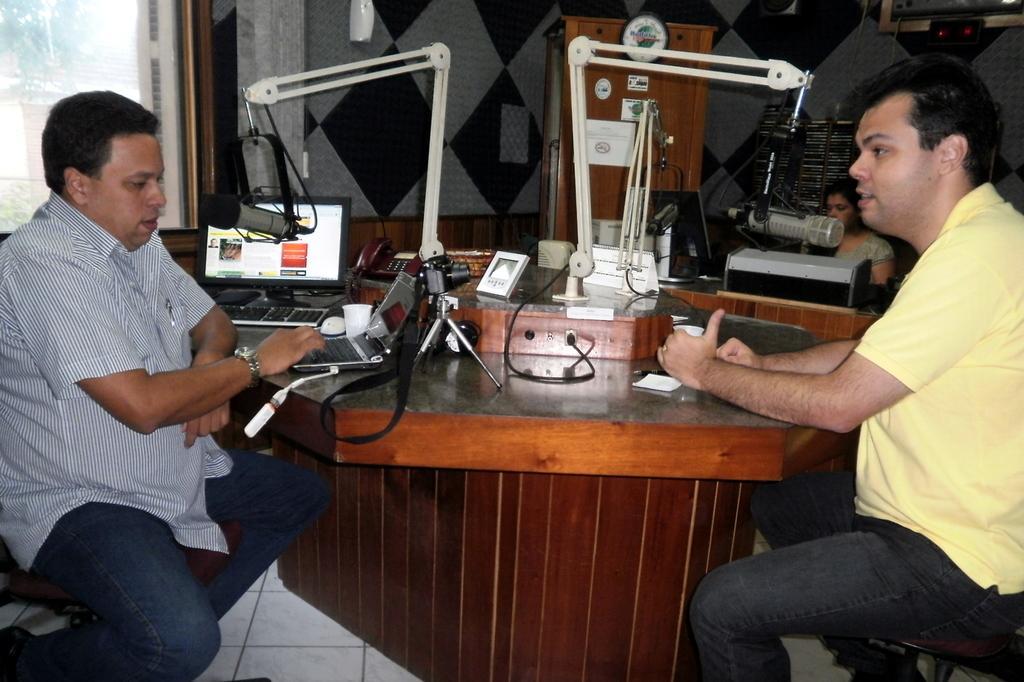Can you describe this image briefly? In this image in the middle there is a table on the table there is laptop ,mouse ,cup and some other items. On the right there is a man he wear yellow t shirt and trouser. On the left there is a man he wear shirt,trouser and watch. In the background there is a woman , wall, mic and window. 